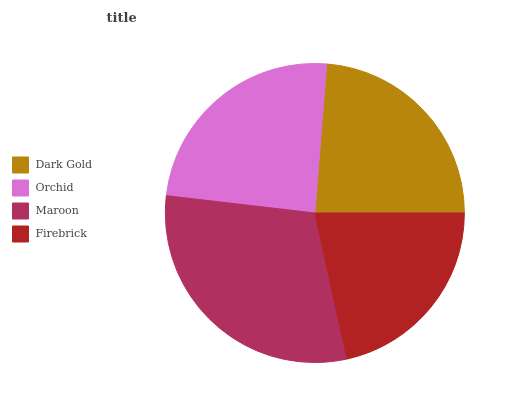Is Firebrick the minimum?
Answer yes or no. Yes. Is Maroon the maximum?
Answer yes or no. Yes. Is Orchid the minimum?
Answer yes or no. No. Is Orchid the maximum?
Answer yes or no. No. Is Orchid greater than Dark Gold?
Answer yes or no. Yes. Is Dark Gold less than Orchid?
Answer yes or no. Yes. Is Dark Gold greater than Orchid?
Answer yes or no. No. Is Orchid less than Dark Gold?
Answer yes or no. No. Is Orchid the high median?
Answer yes or no. Yes. Is Dark Gold the low median?
Answer yes or no. Yes. Is Dark Gold the high median?
Answer yes or no. No. Is Firebrick the low median?
Answer yes or no. No. 